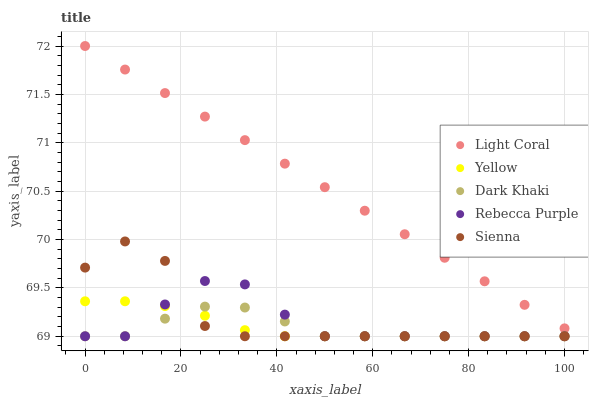Does Dark Khaki have the minimum area under the curve?
Answer yes or no. Yes. Does Light Coral have the maximum area under the curve?
Answer yes or no. Yes. Does Rebecca Purple have the minimum area under the curve?
Answer yes or no. No. Does Rebecca Purple have the maximum area under the curve?
Answer yes or no. No. Is Light Coral the smoothest?
Answer yes or no. Yes. Is Sienna the roughest?
Answer yes or no. Yes. Is Dark Khaki the smoothest?
Answer yes or no. No. Is Dark Khaki the roughest?
Answer yes or no. No. Does Dark Khaki have the lowest value?
Answer yes or no. Yes. Does Light Coral have the highest value?
Answer yes or no. Yes. Does Rebecca Purple have the highest value?
Answer yes or no. No. Is Rebecca Purple less than Light Coral?
Answer yes or no. Yes. Is Light Coral greater than Sienna?
Answer yes or no. Yes. Does Yellow intersect Rebecca Purple?
Answer yes or no. Yes. Is Yellow less than Rebecca Purple?
Answer yes or no. No. Is Yellow greater than Rebecca Purple?
Answer yes or no. No. Does Rebecca Purple intersect Light Coral?
Answer yes or no. No. 